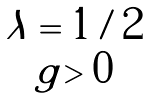Convert formula to latex. <formula><loc_0><loc_0><loc_500><loc_500>\begin{array} { c } \lambda = 1 / 2 \\ g > 0 \end{array}</formula> 